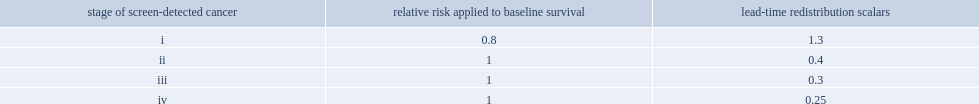Which stage of screen-detected cancer were lead time estimated to be longer for cancers detected at? I. 